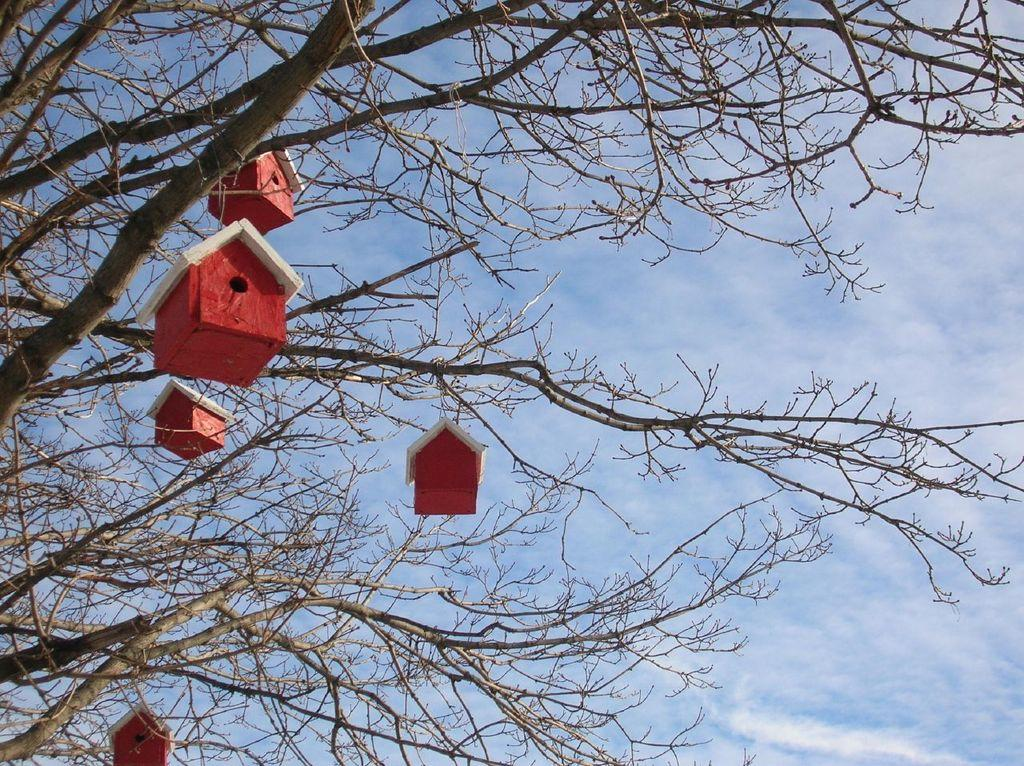What type of structures are hanging from the tree branch in the image? There are house-like structures hanging from a tree branch in the image. How are these structures suspended in the image? The house-like structures are hanging from a tree branch. What can be seen in the background of the image? There is a sky visible in the background of the image. What is the condition of the sky in the image? Clouds are present in the sky. What type of instrument is being played by the banana in the image? There is no banana or instrument present in the image. 